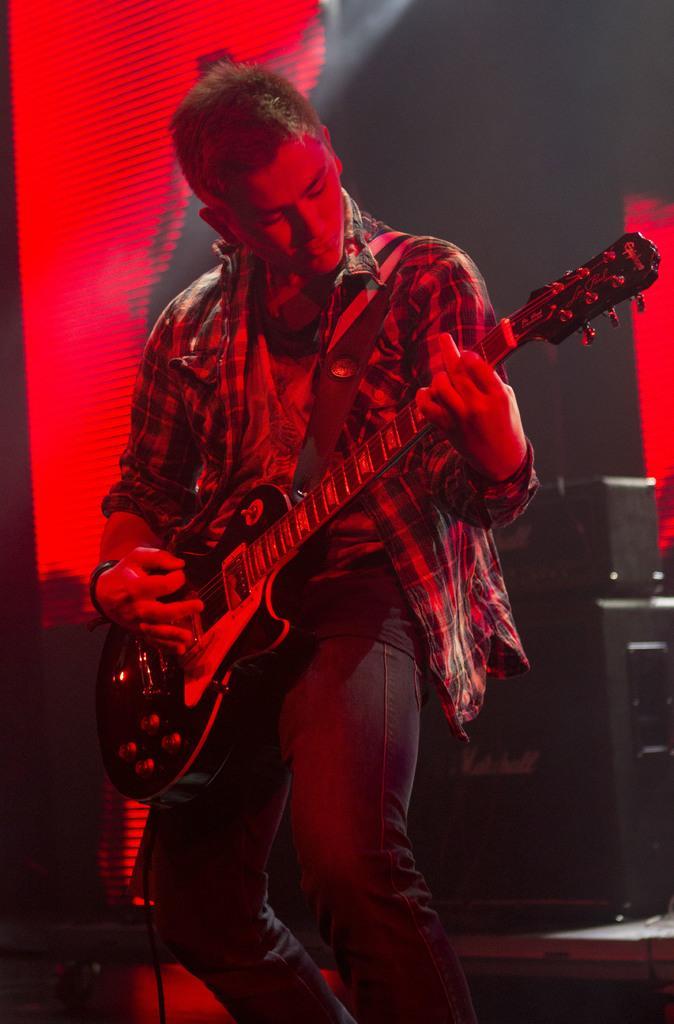Please provide a concise description of this image. In this picture we can see a person standing and playing a guitar, in the background there is a screen, we can see speaker on the right side. 